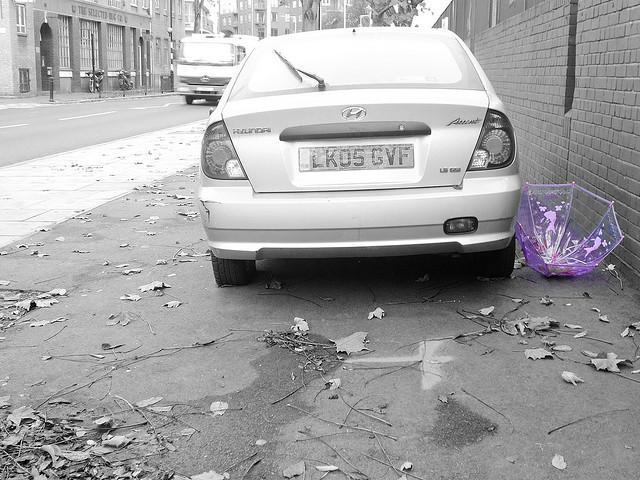How many umbrellas are there?
Give a very brief answer. 1. How many birds are flying?
Give a very brief answer. 0. 